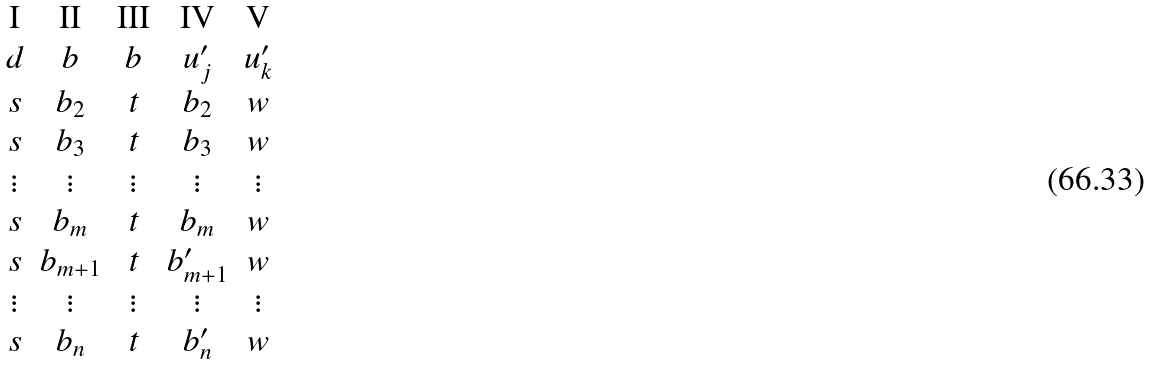<formula> <loc_0><loc_0><loc_500><loc_500>\begin{matrix} \text {I} & \text {II} & \text {III} & \text {IV} & \text {V} \\ d & b & b & u _ { j } ^ { \prime } & u _ { k } ^ { \prime } \\ s & b _ { 2 } & t & b _ { 2 } & w \\ s & b _ { 3 } & t & b _ { 3 } & w \\ \vdots & \vdots & \vdots & \vdots & \vdots \\ s & b _ { m } & t & b _ { m } & w \\ s & b _ { m + 1 } & t & b _ { m + 1 } ^ { \prime } & w \\ \vdots & \vdots & \vdots & \vdots & \vdots \\ s & b _ { n } & t & b _ { n } ^ { \prime } & w \end{matrix}</formula> 